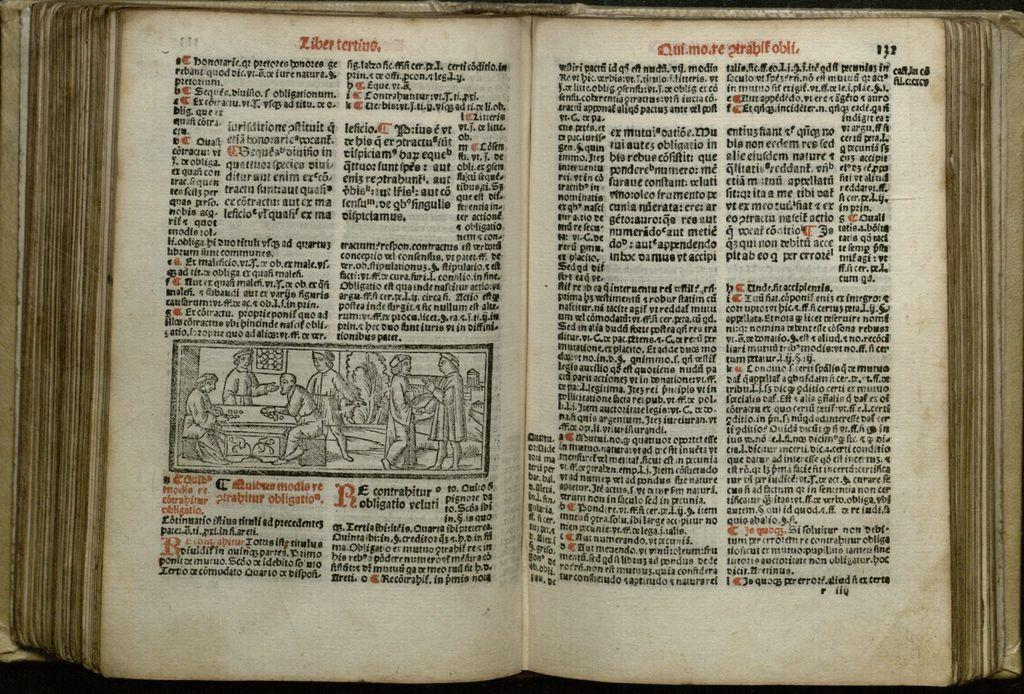<image>
Present a compact description of the photo's key features. Open book on page 122 with the words "Ziber tertine" on top. 